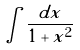Convert formula to latex. <formula><loc_0><loc_0><loc_500><loc_500>\int \frac { d x } { 1 + x ^ { 2 } }</formula> 